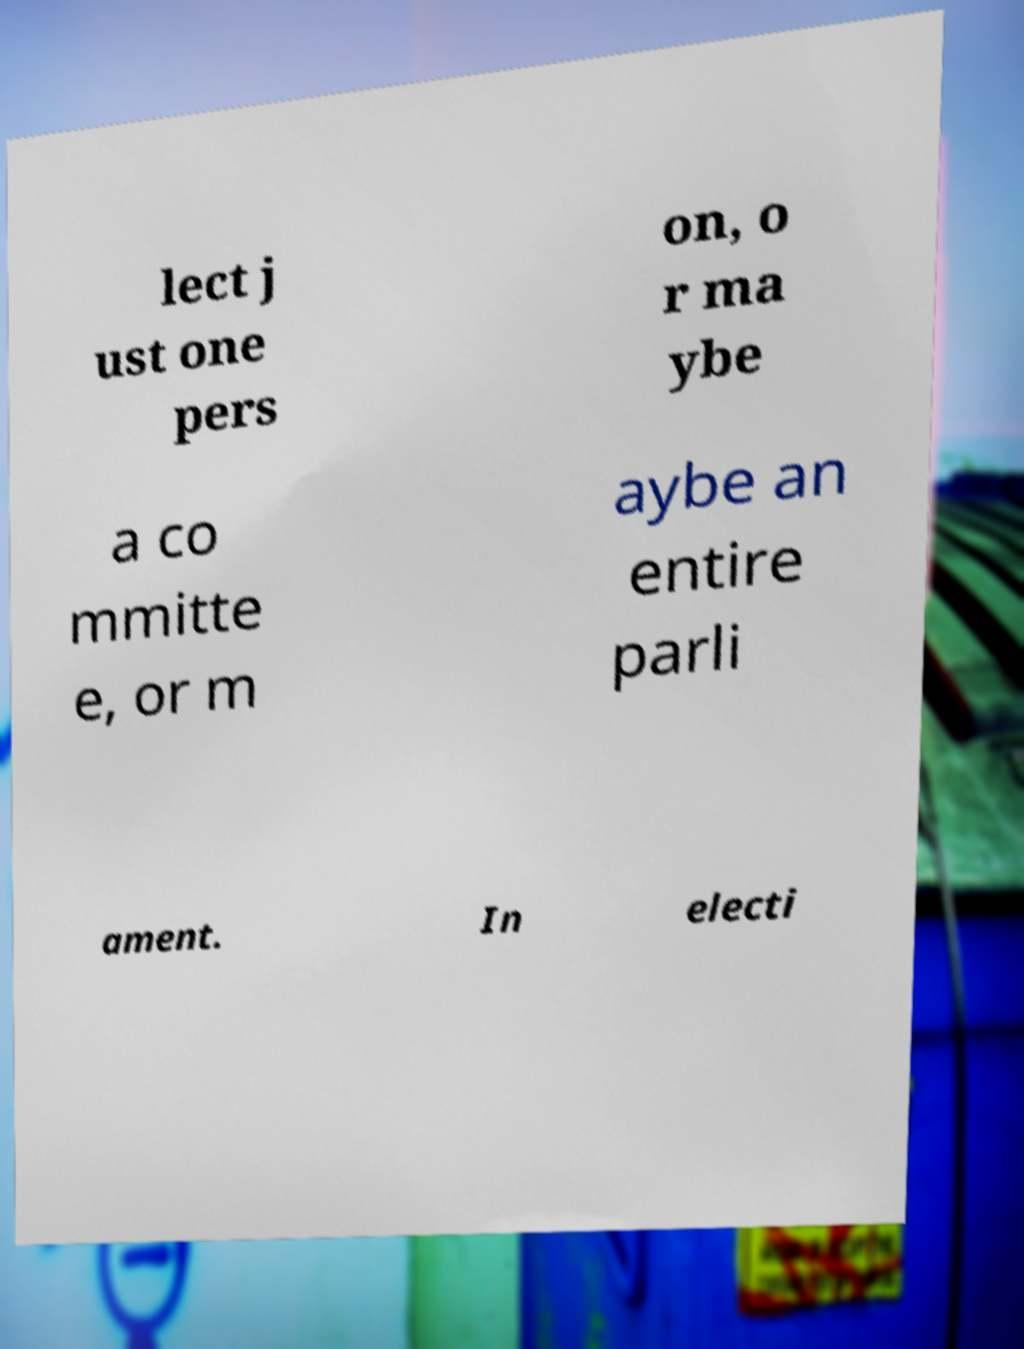Could you assist in decoding the text presented in this image and type it out clearly? lect j ust one pers on, o r ma ybe a co mmitte e, or m aybe an entire parli ament. In electi 